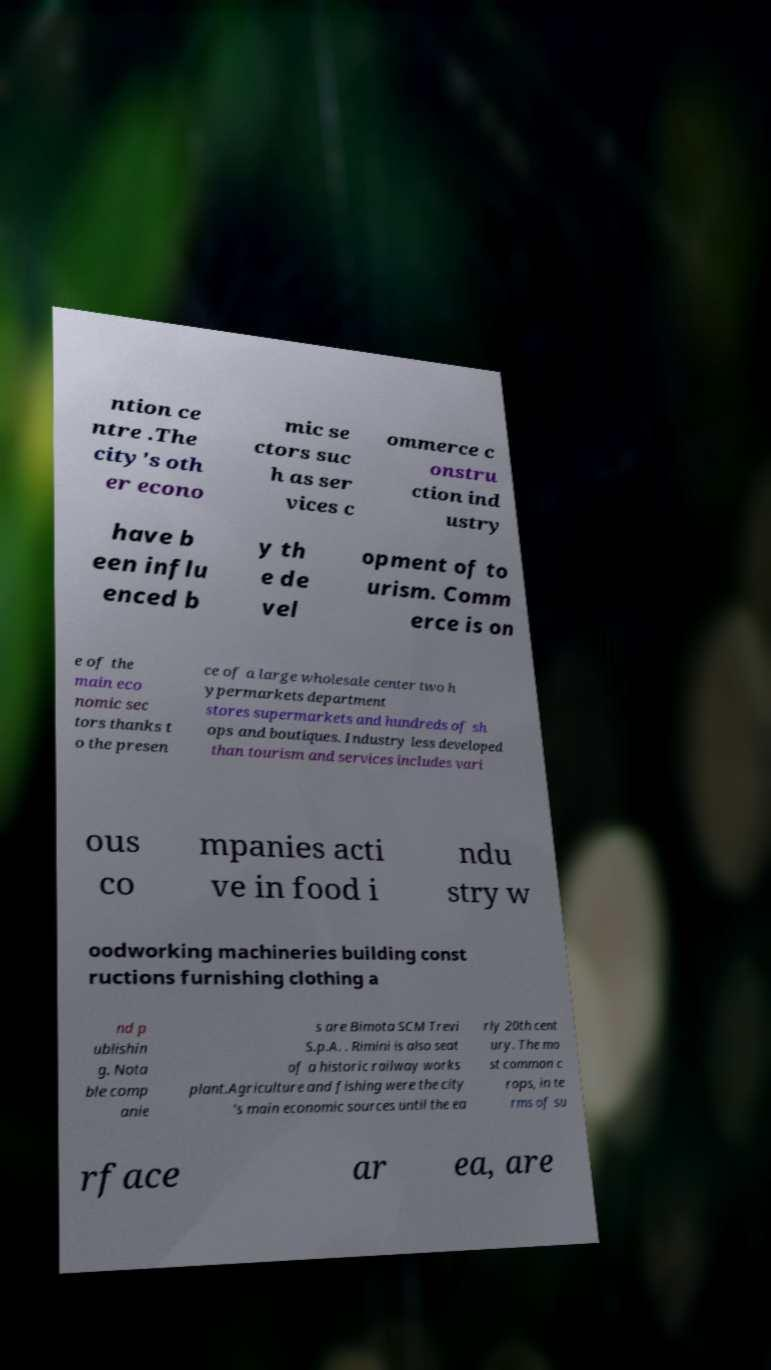What messages or text are displayed in this image? I need them in a readable, typed format. ntion ce ntre .The city's oth er econo mic se ctors suc h as ser vices c ommerce c onstru ction ind ustry have b een influ enced b y th e de vel opment of to urism. Comm erce is on e of the main eco nomic sec tors thanks t o the presen ce of a large wholesale center two h ypermarkets department stores supermarkets and hundreds of sh ops and boutiques. Industry less developed than tourism and services includes vari ous co mpanies acti ve in food i ndu stry w oodworking machineries building const ructions furnishing clothing a nd p ublishin g. Nota ble comp anie s are Bimota SCM Trevi S.p.A. . Rimini is also seat of a historic railway works plant.Agriculture and fishing were the city 's main economic sources until the ea rly 20th cent ury. The mo st common c rops, in te rms of su rface ar ea, are 